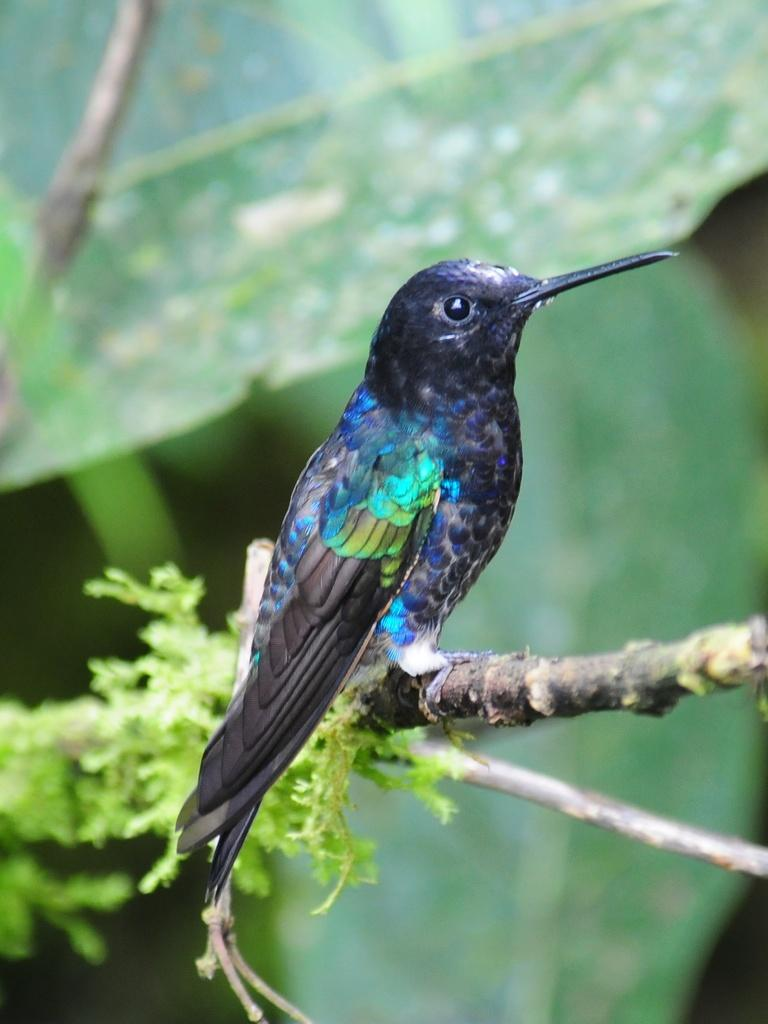What type of animal can be seen in the image? There is a bird in the image. Where is the bird located in the image? The bird is sitting on a branch. What is the branch a part of? The branch is part of a plant. What can be observed in the image besides the bird and the branch? There are many leaves in the image. What scent can be detected from the bird in the image? There is no information about the scent of the bird in the image, and therefore it cannot be determined. 